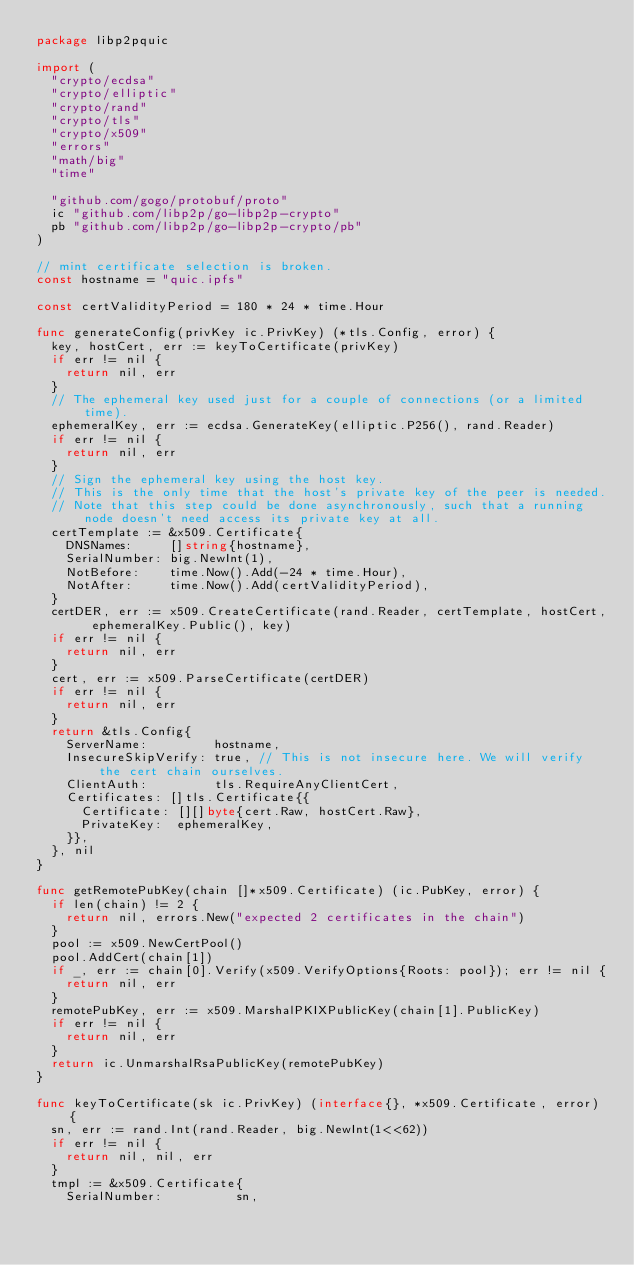Convert code to text. <code><loc_0><loc_0><loc_500><loc_500><_Go_>package libp2pquic

import (
	"crypto/ecdsa"
	"crypto/elliptic"
	"crypto/rand"
	"crypto/tls"
	"crypto/x509"
	"errors"
	"math/big"
	"time"

	"github.com/gogo/protobuf/proto"
	ic "github.com/libp2p/go-libp2p-crypto"
	pb "github.com/libp2p/go-libp2p-crypto/pb"
)

// mint certificate selection is broken.
const hostname = "quic.ipfs"

const certValidityPeriod = 180 * 24 * time.Hour

func generateConfig(privKey ic.PrivKey) (*tls.Config, error) {
	key, hostCert, err := keyToCertificate(privKey)
	if err != nil {
		return nil, err
	}
	// The ephemeral key used just for a couple of connections (or a limited time).
	ephemeralKey, err := ecdsa.GenerateKey(elliptic.P256(), rand.Reader)
	if err != nil {
		return nil, err
	}
	// Sign the ephemeral key using the host key.
	// This is the only time that the host's private key of the peer is needed.
	// Note that this step could be done asynchronously, such that a running node doesn't need access its private key at all.
	certTemplate := &x509.Certificate{
		DNSNames:     []string{hostname},
		SerialNumber: big.NewInt(1),
		NotBefore:    time.Now().Add(-24 * time.Hour),
		NotAfter:     time.Now().Add(certValidityPeriod),
	}
	certDER, err := x509.CreateCertificate(rand.Reader, certTemplate, hostCert, ephemeralKey.Public(), key)
	if err != nil {
		return nil, err
	}
	cert, err := x509.ParseCertificate(certDER)
	if err != nil {
		return nil, err
	}
	return &tls.Config{
		ServerName:         hostname,
		InsecureSkipVerify: true, // This is not insecure here. We will verify the cert chain ourselves.
		ClientAuth:         tls.RequireAnyClientCert,
		Certificates: []tls.Certificate{{
			Certificate: [][]byte{cert.Raw, hostCert.Raw},
			PrivateKey:  ephemeralKey,
		}},
	}, nil
}

func getRemotePubKey(chain []*x509.Certificate) (ic.PubKey, error) {
	if len(chain) != 2 {
		return nil, errors.New("expected 2 certificates in the chain")
	}
	pool := x509.NewCertPool()
	pool.AddCert(chain[1])
	if _, err := chain[0].Verify(x509.VerifyOptions{Roots: pool}); err != nil {
		return nil, err
	}
	remotePubKey, err := x509.MarshalPKIXPublicKey(chain[1].PublicKey)
	if err != nil {
		return nil, err
	}
	return ic.UnmarshalRsaPublicKey(remotePubKey)
}

func keyToCertificate(sk ic.PrivKey) (interface{}, *x509.Certificate, error) {
	sn, err := rand.Int(rand.Reader, big.NewInt(1<<62))
	if err != nil {
		return nil, nil, err
	}
	tmpl := &x509.Certificate{
		SerialNumber:          sn,</code> 